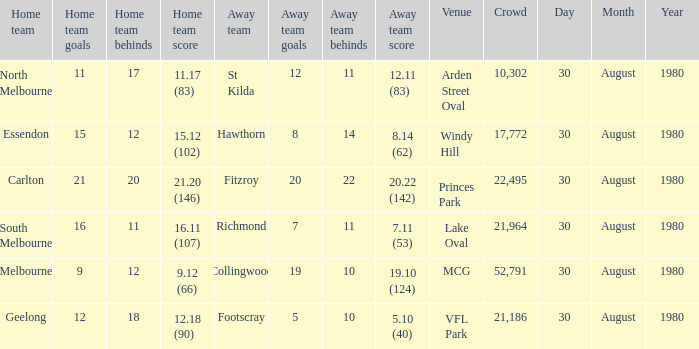What was the crowd when the away team is footscray? 21186.0. 